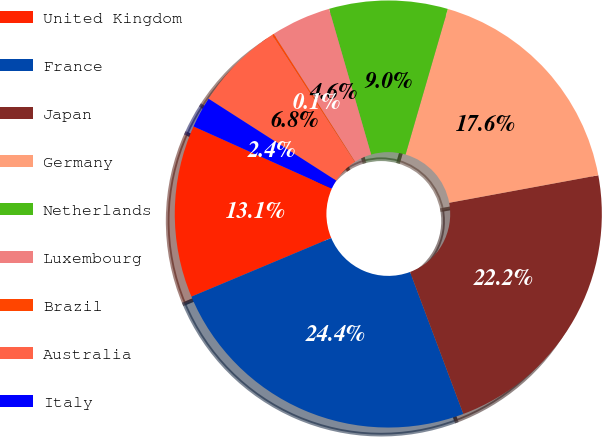Convert chart to OTSL. <chart><loc_0><loc_0><loc_500><loc_500><pie_chart><fcel>United Kingdom<fcel>France<fcel>Japan<fcel>Germany<fcel>Netherlands<fcel>Luxembourg<fcel>Brazil<fcel>Australia<fcel>Italy<nl><fcel>13.05%<fcel>24.39%<fcel>22.19%<fcel>17.6%<fcel>8.97%<fcel>4.55%<fcel>0.14%<fcel>6.76%<fcel>2.35%<nl></chart> 